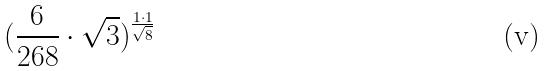<formula> <loc_0><loc_0><loc_500><loc_500>( \frac { 6 } { 2 6 8 } \cdot \sqrt { 3 } ) ^ { \frac { 1 \cdot 1 } { \sqrt { 8 } } }</formula> 